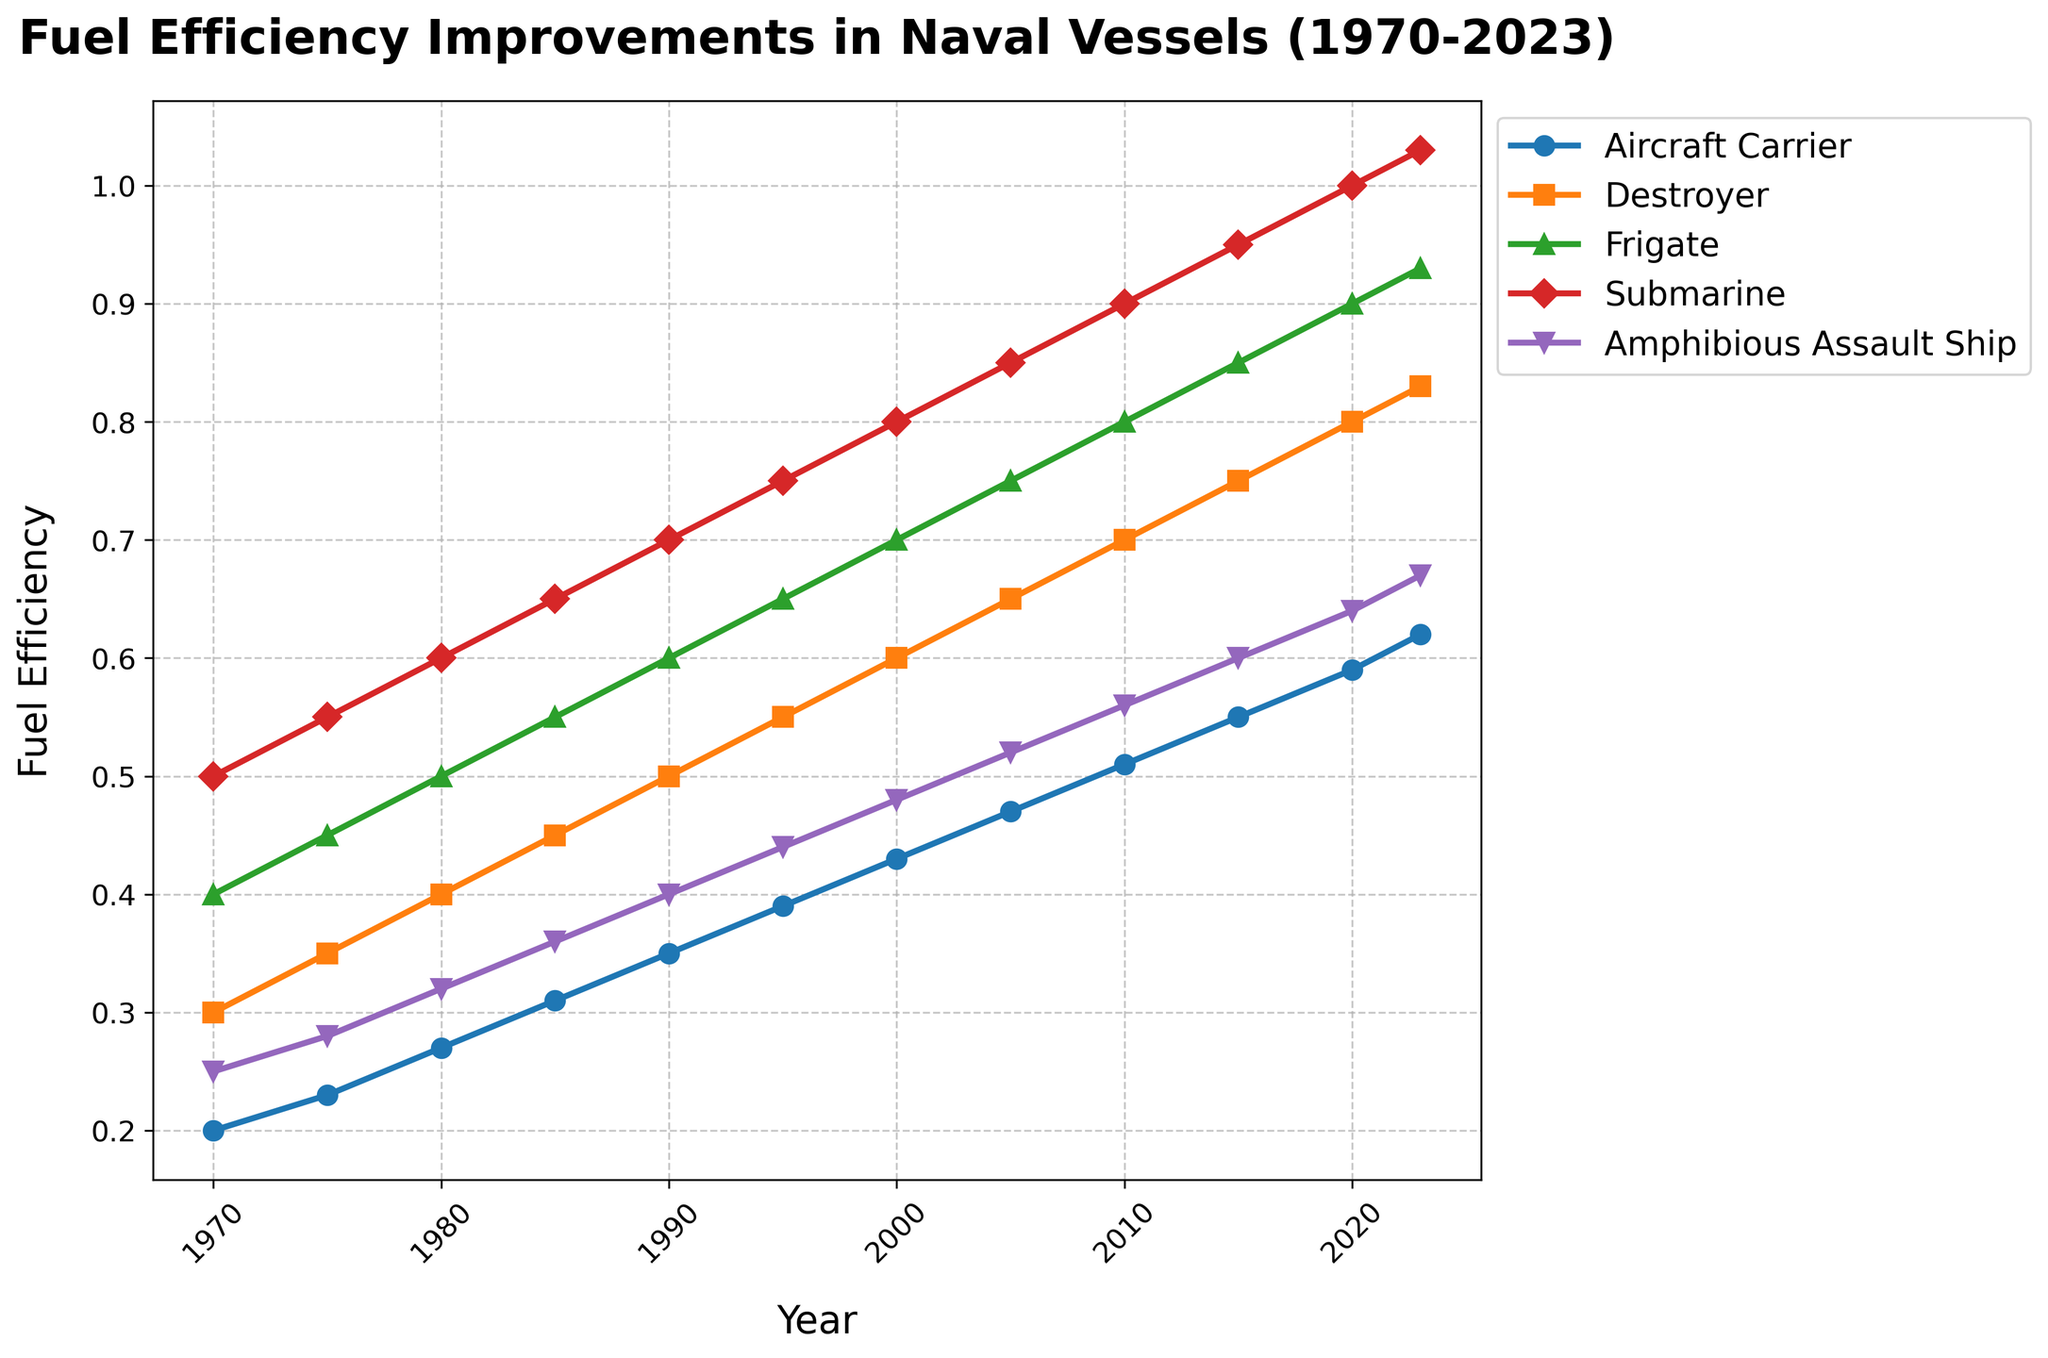Which vessel class had the highest fuel efficiency in 2023? Look for the highest point in 2023 across all lines. The Submarine class shows the highest value.
Answer: Submarine How did the fuel efficiency of the Destroyer class change from 1970 to 2023? Check the start and end points of the line representing Destroyers. It starts at 0.3 in 1970 and ends at 0.83 in 2023. The change is 0.83 - 0.3.
Answer: Increased by 0.53 Which vessel class had the least improvement in fuel efficiency from 1970 to 2023? Calculate the difference between 1970 and 2023 values for each class. The Aircraft Carrier shows the smallest change: 0.62 - 0.2 = 0.42.
Answer: Aircraft Carrier Between which years did the Amphibious Assault Ship class show the most significant fuel efficiency improvement? Inspect the line representing Amphibious Assault Ships and compare the slopes. The steepest slope appears between 1990 and 1995, where the efficiency increases from 0.4 to 0.44.
Answer: 1990-1995 In what year did Frigates first surpass a fuel efficiency of 0.5? Track the line representing Frigates and find the first year where it crosses the 0.5 mark. This occurs in 1980.
Answer: 1980 Which vessel class exhibited the most consistent improvement in fuel efficiency over the years? Look for the line with the most uniform slope. The Submarine class line appears the most consistent with a steady, uniform rise.
Answer: Submarine How much more fuel efficient was the Amphibious Assault Ship in 2023 compared to 1975? Subtract the fuel efficiency value in 1975 from that in 2023 for the Amphibious Assault Ship. The calculation is 0.67 - 0.28.
Answer: 0.39 What is the fuel efficiency difference between the Submarine and Frigate classes in 2023? Subtract the fuel efficiency value of the Frigate class from that of the Submarine class in 2023: 1.03 - 0.93.
Answer: 0.1 Which two vessel classes had exactly matching fuel efficiencies in any given year within the provided data? Check for any years where two lines overlap. In 1970, the Amphibious Assault Ship and Aircraft Carrier both had the same value of 0.25.
Answer: Amphibious Assault Ship and Aircraft Carrier in 1970 